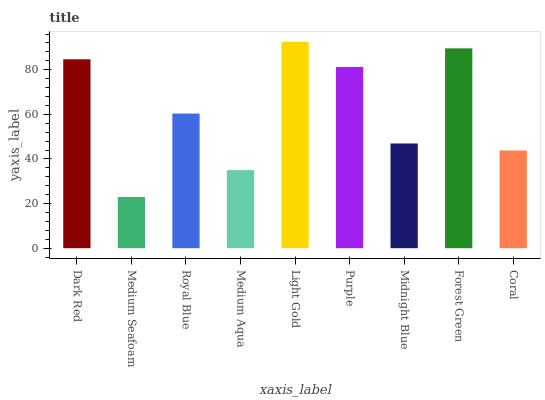Is Medium Seafoam the minimum?
Answer yes or no. Yes. Is Light Gold the maximum?
Answer yes or no. Yes. Is Royal Blue the minimum?
Answer yes or no. No. Is Royal Blue the maximum?
Answer yes or no. No. Is Royal Blue greater than Medium Seafoam?
Answer yes or no. Yes. Is Medium Seafoam less than Royal Blue?
Answer yes or no. Yes. Is Medium Seafoam greater than Royal Blue?
Answer yes or no. No. Is Royal Blue less than Medium Seafoam?
Answer yes or no. No. Is Royal Blue the high median?
Answer yes or no. Yes. Is Royal Blue the low median?
Answer yes or no. Yes. Is Midnight Blue the high median?
Answer yes or no. No. Is Coral the low median?
Answer yes or no. No. 